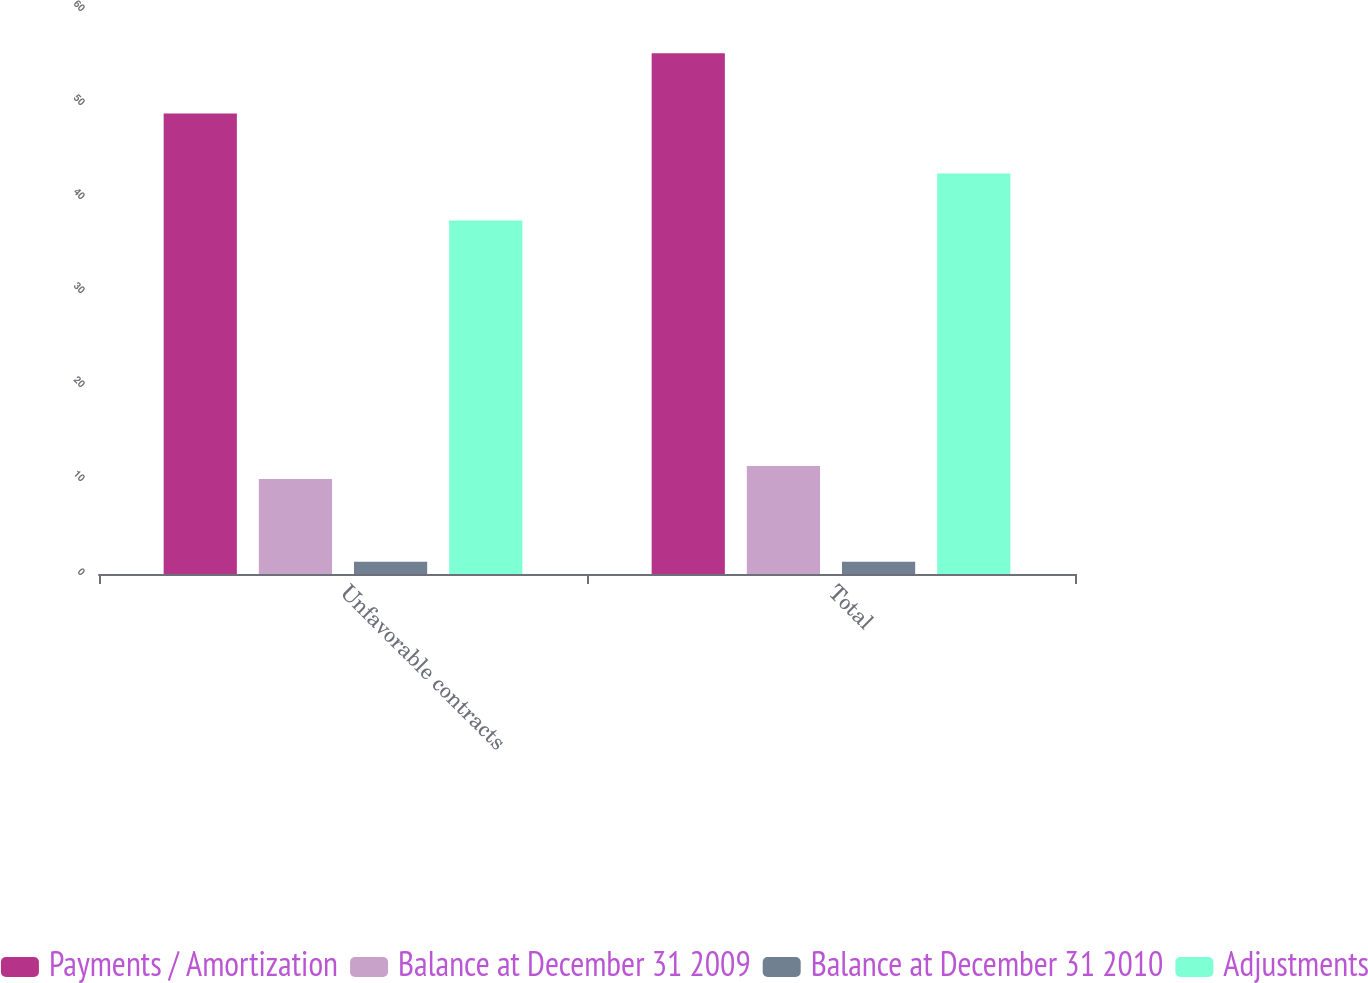<chart> <loc_0><loc_0><loc_500><loc_500><stacked_bar_chart><ecel><fcel>Unfavorable contracts<fcel>Total<nl><fcel>Payments / Amortization<fcel>49<fcel>55.4<nl><fcel>Balance at December 31 2009<fcel>10.1<fcel>11.5<nl><fcel>Balance at December 31 2010<fcel>1.3<fcel>1.3<nl><fcel>Adjustments<fcel>37.6<fcel>42.6<nl></chart> 